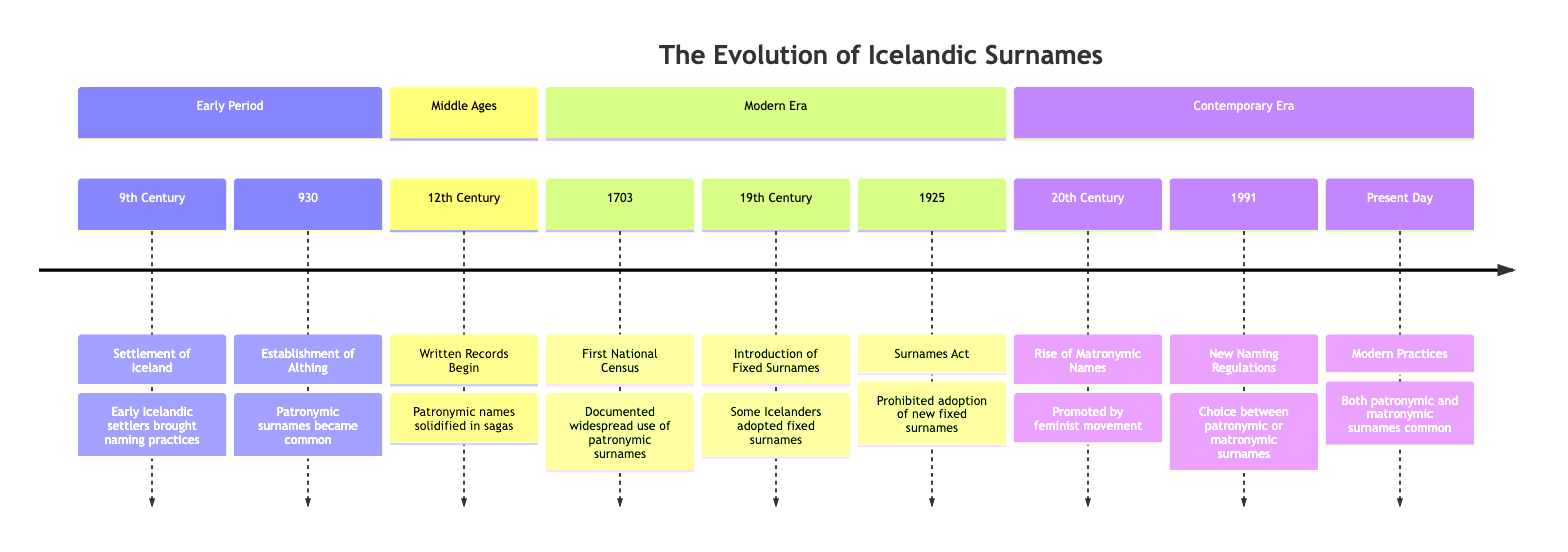What year did the first national census occur? The timeline states that the first national census in Iceland took place in 1703. This is explicitly mentioned as a key event in the modern era section of the timeline.
Answer: 1703 What became common following the establishment of the Althing? According to the timeline, after the establishment of the Althing in 930, patronymic surnames became commonly used. This event is noted in the early period section.
Answer: Patronymic surnames In which century did the rise of matronymic names start? The diagram indicates that the rise of matronymic names occurred in the 20th century, marking a significant shift in naming practices influenced by social changes.
Answer: 20th Century What act was established in 1925 regarding surnames? The timeline highlights the Surnames Act in 1925, which prohibited the adoption of new fixed surnames and reinforced the traditions of patronymic and matronymic naming conventions.
Answer: Surnames Act How did the 1991 naming regulations change Icelandic naming practices? The timeline states that the 1991 naming regulations allowed parents to choose between patronymic or matronymic surnames. This illustrates a move towards gender equality in naming conventions.
Answer: Allowed choice What is noted about the written records that began in the 12th century? In the timeline, it is stated that the tradition of recording genealogies and sagas began in the 12th century, which solidified the use of patronymic names through notable works.
Answer: Written records How did the introduction of fixed surnames in the 19th century affect naming conventions? The timeline explains that in the 19th century, some Icelanders began adopting fixed surnames, influenced by other European practices. This indicates a deviation from traditional naming practices.
Answer: Fixed surnames Which century marks the establishment of the Althing? The timeline clearly states that the Althing was established in the year 930, placing it in the 10th century of Icelandic history.
Answer: 10th Century What influence did the feminist movement have in the 20th century on Icelandic surnames? According to the timeline, the feminist movement in the 20th century promoted the use of matronymic names, representing a societal shift towards gender equality in naming.
Answer: Promoted matronymics 